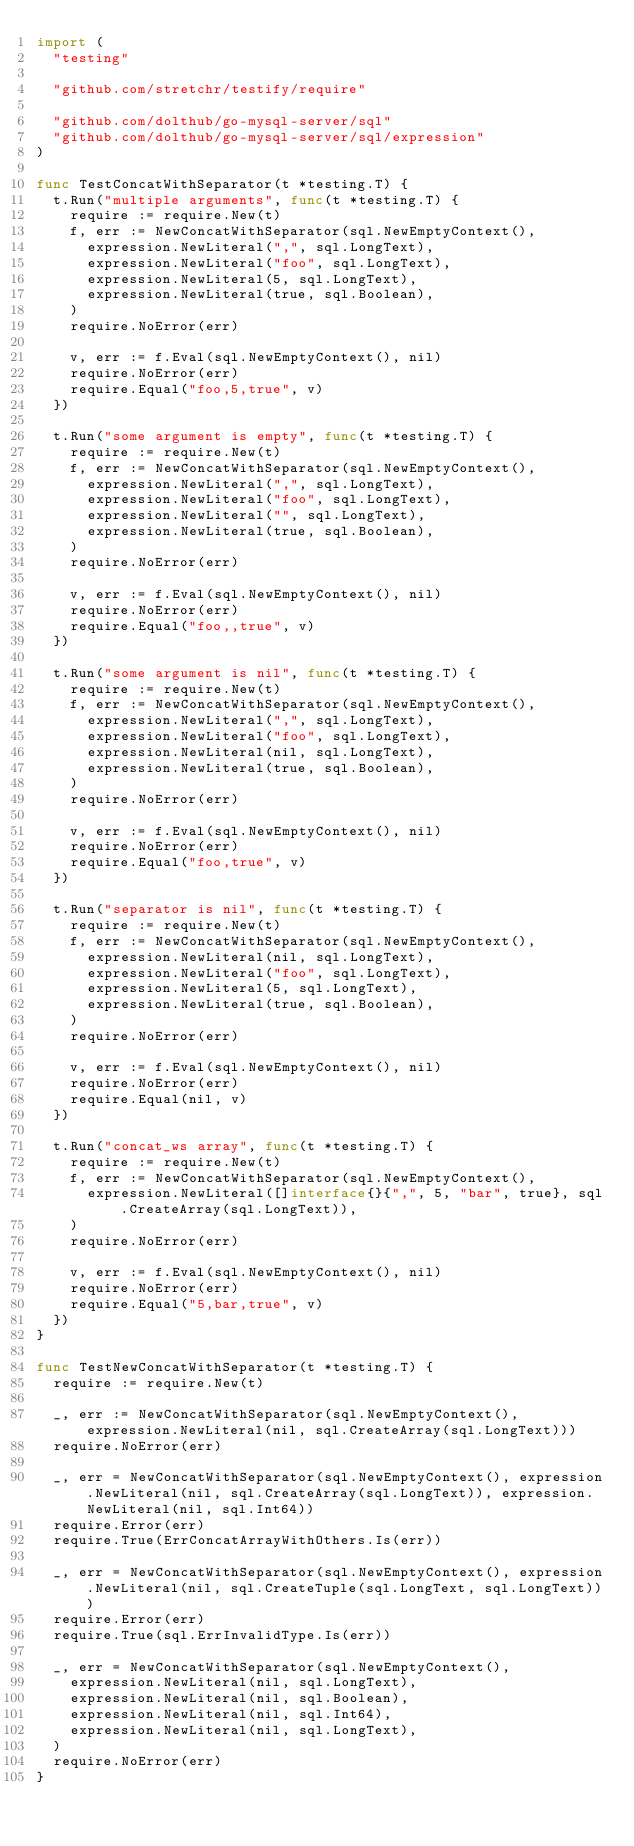<code> <loc_0><loc_0><loc_500><loc_500><_Go_>import (
	"testing"

	"github.com/stretchr/testify/require"

	"github.com/dolthub/go-mysql-server/sql"
	"github.com/dolthub/go-mysql-server/sql/expression"
)

func TestConcatWithSeparator(t *testing.T) {
	t.Run("multiple arguments", func(t *testing.T) {
		require := require.New(t)
		f, err := NewConcatWithSeparator(sql.NewEmptyContext(),
			expression.NewLiteral(",", sql.LongText),
			expression.NewLiteral("foo", sql.LongText),
			expression.NewLiteral(5, sql.LongText),
			expression.NewLiteral(true, sql.Boolean),
		)
		require.NoError(err)

		v, err := f.Eval(sql.NewEmptyContext(), nil)
		require.NoError(err)
		require.Equal("foo,5,true", v)
	})

	t.Run("some argument is empty", func(t *testing.T) {
		require := require.New(t)
		f, err := NewConcatWithSeparator(sql.NewEmptyContext(),
			expression.NewLiteral(",", sql.LongText),
			expression.NewLiteral("foo", sql.LongText),
			expression.NewLiteral("", sql.LongText),
			expression.NewLiteral(true, sql.Boolean),
		)
		require.NoError(err)

		v, err := f.Eval(sql.NewEmptyContext(), nil)
		require.NoError(err)
		require.Equal("foo,,true", v)
	})

	t.Run("some argument is nil", func(t *testing.T) {
		require := require.New(t)
		f, err := NewConcatWithSeparator(sql.NewEmptyContext(),
			expression.NewLiteral(",", sql.LongText),
			expression.NewLiteral("foo", sql.LongText),
			expression.NewLiteral(nil, sql.LongText),
			expression.NewLiteral(true, sql.Boolean),
		)
		require.NoError(err)

		v, err := f.Eval(sql.NewEmptyContext(), nil)
		require.NoError(err)
		require.Equal("foo,true", v)
	})

	t.Run("separator is nil", func(t *testing.T) {
		require := require.New(t)
		f, err := NewConcatWithSeparator(sql.NewEmptyContext(),
			expression.NewLiteral(nil, sql.LongText),
			expression.NewLiteral("foo", sql.LongText),
			expression.NewLiteral(5, sql.LongText),
			expression.NewLiteral(true, sql.Boolean),
		)
		require.NoError(err)

		v, err := f.Eval(sql.NewEmptyContext(), nil)
		require.NoError(err)
		require.Equal(nil, v)
	})

	t.Run("concat_ws array", func(t *testing.T) {
		require := require.New(t)
		f, err := NewConcatWithSeparator(sql.NewEmptyContext(),
			expression.NewLiteral([]interface{}{",", 5, "bar", true}, sql.CreateArray(sql.LongText)),
		)
		require.NoError(err)

		v, err := f.Eval(sql.NewEmptyContext(), nil)
		require.NoError(err)
		require.Equal("5,bar,true", v)
	})
}

func TestNewConcatWithSeparator(t *testing.T) {
	require := require.New(t)

	_, err := NewConcatWithSeparator(sql.NewEmptyContext(), expression.NewLiteral(nil, sql.CreateArray(sql.LongText)))
	require.NoError(err)

	_, err = NewConcatWithSeparator(sql.NewEmptyContext(), expression.NewLiteral(nil, sql.CreateArray(sql.LongText)), expression.NewLiteral(nil, sql.Int64))
	require.Error(err)
	require.True(ErrConcatArrayWithOthers.Is(err))

	_, err = NewConcatWithSeparator(sql.NewEmptyContext(), expression.NewLiteral(nil, sql.CreateTuple(sql.LongText, sql.LongText)))
	require.Error(err)
	require.True(sql.ErrInvalidType.Is(err))

	_, err = NewConcatWithSeparator(sql.NewEmptyContext(),
		expression.NewLiteral(nil, sql.LongText),
		expression.NewLiteral(nil, sql.Boolean),
		expression.NewLiteral(nil, sql.Int64),
		expression.NewLiteral(nil, sql.LongText),
	)
	require.NoError(err)
}
</code> 